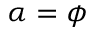<formula> <loc_0><loc_0><loc_500><loc_500>\alpha = \phi</formula> 